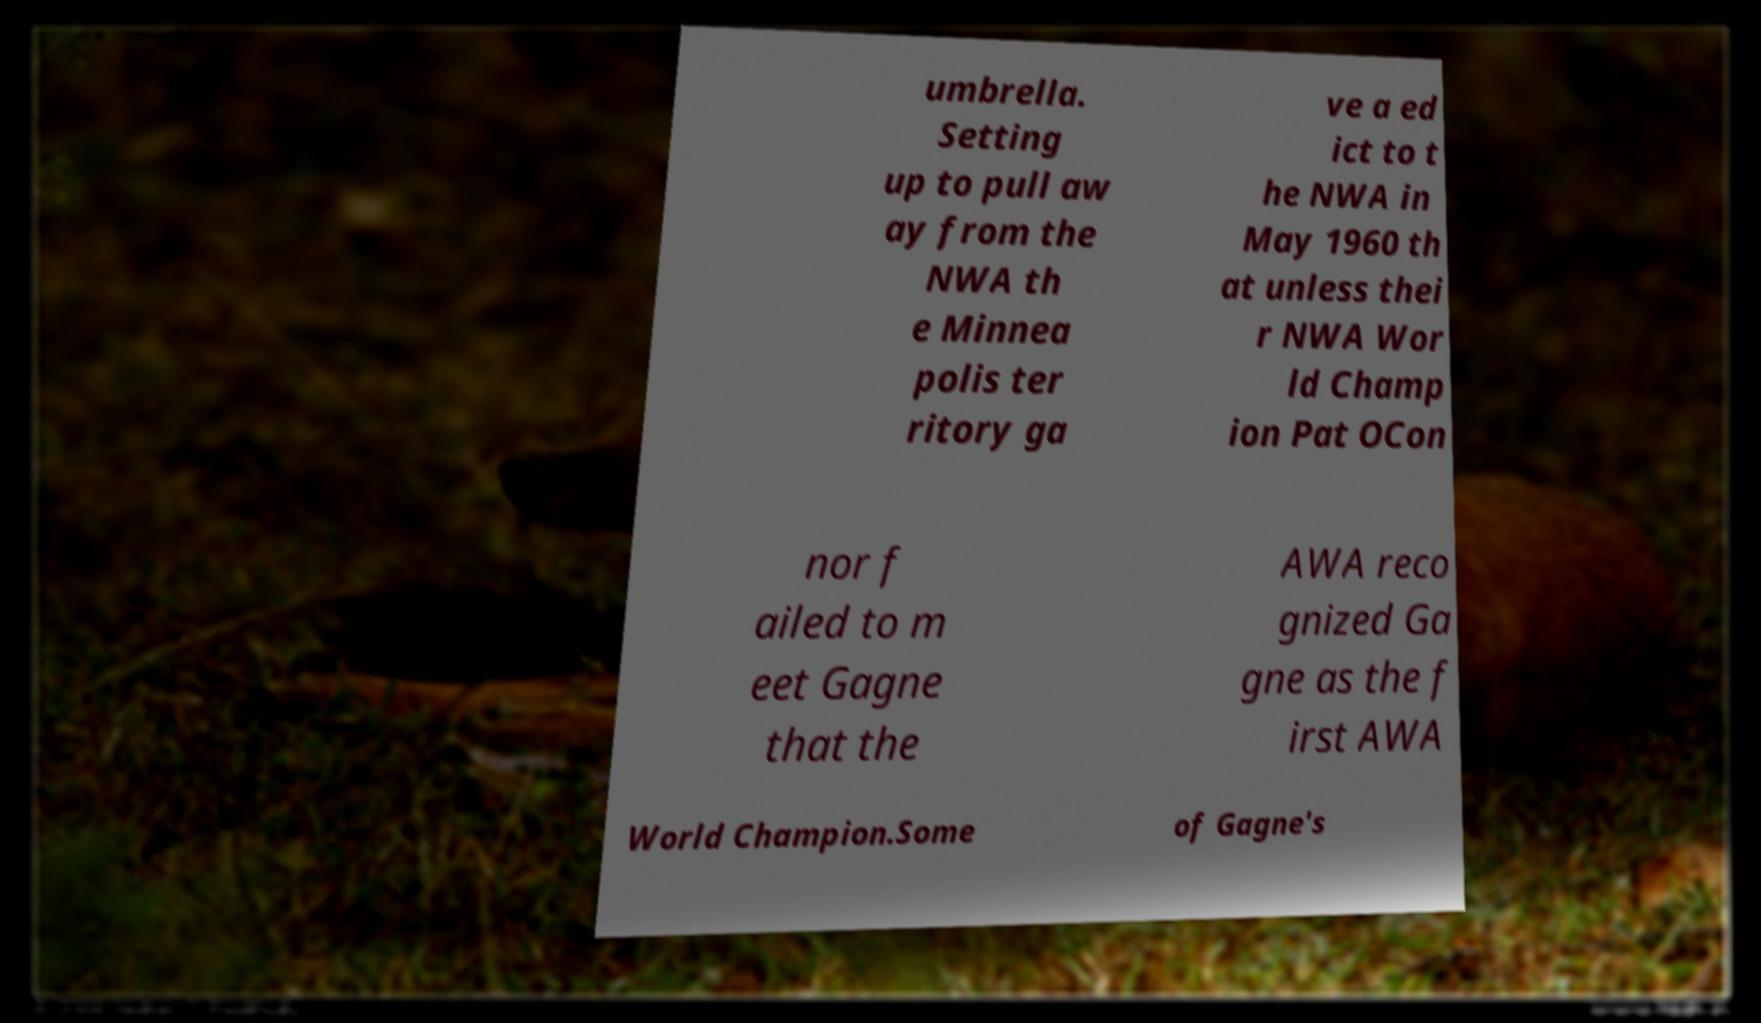For documentation purposes, I need the text within this image transcribed. Could you provide that? umbrella. Setting up to pull aw ay from the NWA th e Minnea polis ter ritory ga ve a ed ict to t he NWA in May 1960 th at unless thei r NWA Wor ld Champ ion Pat OCon nor f ailed to m eet Gagne that the AWA reco gnized Ga gne as the f irst AWA World Champion.Some of Gagne's 